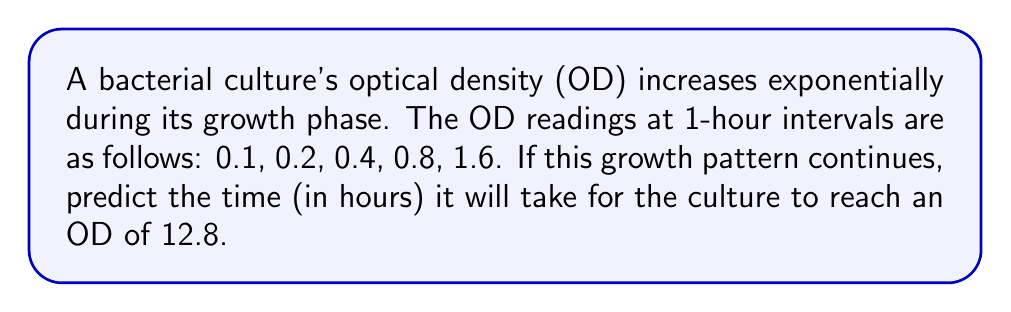Solve this math problem. Let's approach this step-by-step:

1) First, we need to identify the pattern in the sequence. We can see that each term is doubling:

   $0.1 \rightarrow 0.2 \rightarrow 0.4 \rightarrow 0.8 \rightarrow 1.6$

2) This suggests an exponential growth with a base of 2. We can express this as:

   $OD = 0.1 \times 2^n$

   Where $n$ is the number of hours.

3) We want to find $n$ when $OD = 12.8$. Let's set up the equation:

   $12.8 = 0.1 \times 2^n$

4) To solve for $n$, let's divide both sides by 0.1:

   $128 = 2^n$

5) Now we can take the logarithm (base 2) of both sides:

   $\log_2(128) = \log_2(2^n)$

6) The right side simplifies to $n$:

   $\log_2(128) = n$

7) $128 = 2^7$, so $\log_2(128) = 7$

Therefore, it will take 7 hours for the culture to reach an OD of 12.8.
Answer: 7 hours 